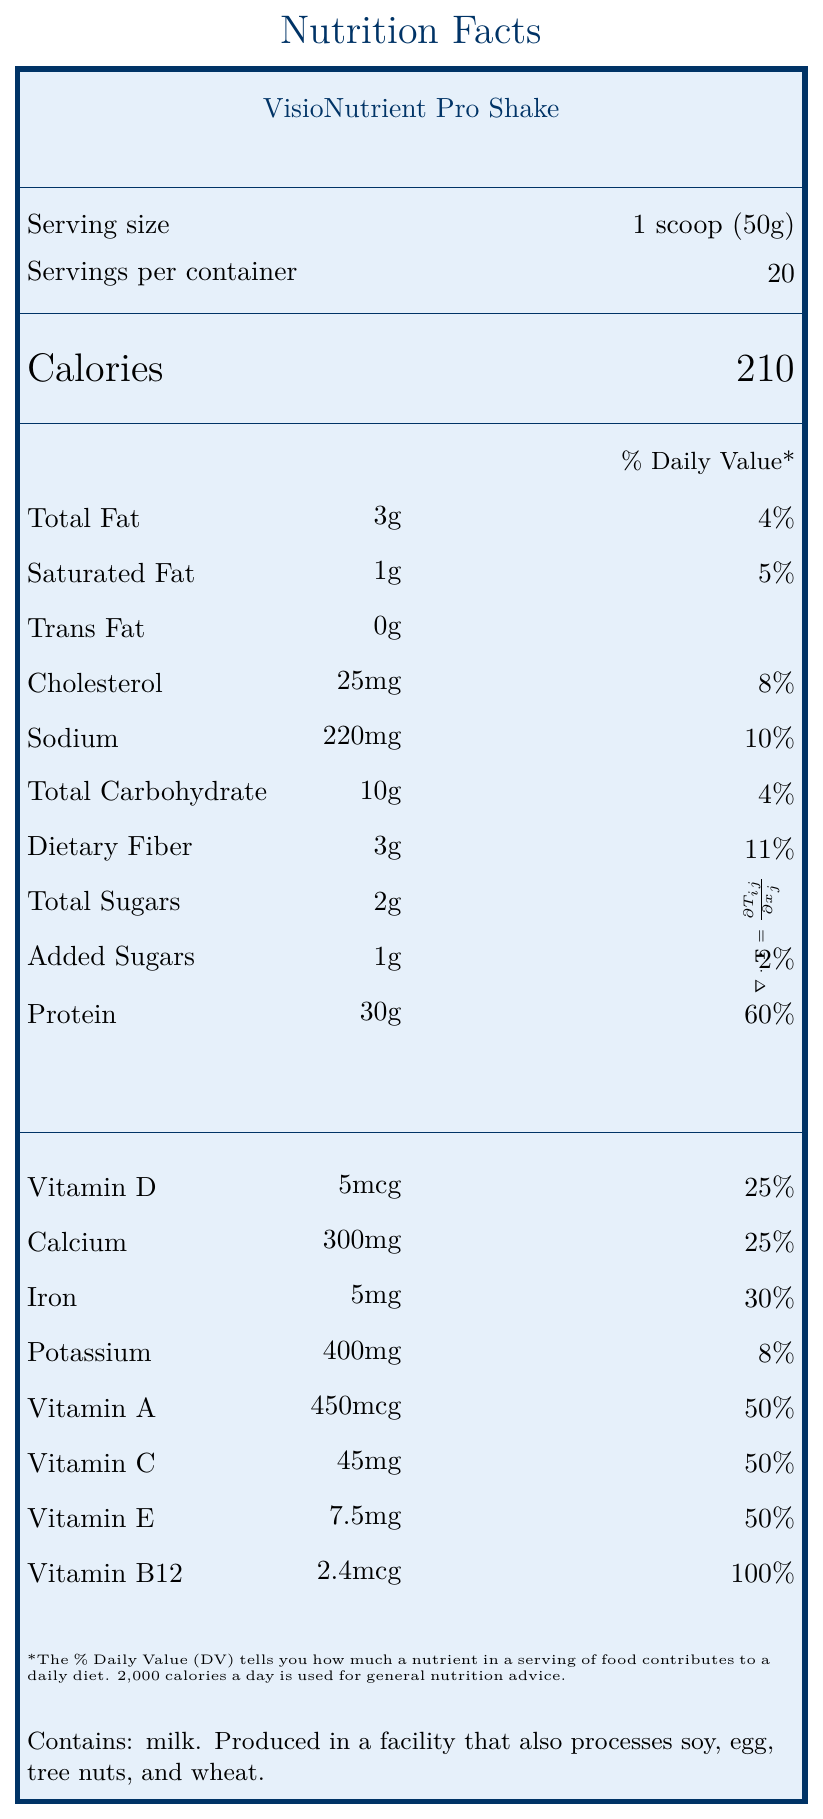what is the product name? The product name is clearly stated at the top of the document.
Answer: VisioNutrient Pro Shake what is the serving size? The serving size is noted as "1 scoop (50g)" next to the label "Serving size".
Answer: 1 scoop (50g) how many calories are in one serving? The calorie content per serving is highlighted as 210 calories near the top of the document.
Answer: 210 how much protein is in one serving? The protein content per serving is listed as 30g with a 60% daily value.
Answer: 30g what are the ingredients? The ingredient list is found towards the bottom of the document.
Answer: Whey protein isolate, pea protein, medium-chain triglycerides, soluble corn fiber, natural flavors, sunflower lecithin, stevia leaf extract, xanthan gum, salt which nutrient has the highest daily value percentage? A. Sodium B. Vitamin A C. Protein D. Vitamin B12 Vitamin B12 has a 100% daily value, which is higher than any other nutrient listed.
Answer: D. Vitamin B12 what is the daily value percentage of dietary fiber? The document shows dietary fiber has a daily value of 11%.
Answer: 11% does the product contain vitamin D? The document lists vitamin D with an amount of 5mcg and a 25% daily value.
Answer: Yes describe the main features of the document. The summary covers the essential elements of the document including nutritional data, accessible features, and collaborative development.
Answer: The document provides detailed nutritional information about VisioNutrient Pro Shake, including serving size, calories, and daily values for various nutrients like total fat, sodium, total carbohydrates, protein, and vitamins. It also highlights accessible features such as Braille overlay, QR code for an audio description, and tactile indicators. Additionally, it includes allergen information and mentions that the product was developed in collaboration with the Institute for Accessible Nutrition at Cambridge University. what is the contact phone number for additional information? The contact phone number mentioned in the contact information section is 1-800-555-0123.
Answer: 1-800-555-0123 does the product contain peanuts? The document states that the product is produced in a facility that processes tree nuts, but it does not specify whether peanuts are part of the tree nuts mentioned.
Answer: Cannot be determined which vitamins are present at 50% of the daily value or more? A. Vitamin D and Calcium B. Iron and Potassium C. Vitamin A and Vitamin C D. Sodium and Protein The document lists Vitamin A, Vitamin C, and Vitamin E each at 50% daily value, making C the correct answer for vitamins at 50%.
Answer: C. Vitamin A and Vitamin C does the document mention the sustainability of the packaging? The document includes information stating that the container is made from 100% post-consumer recycled materials.
Answer: Yes 